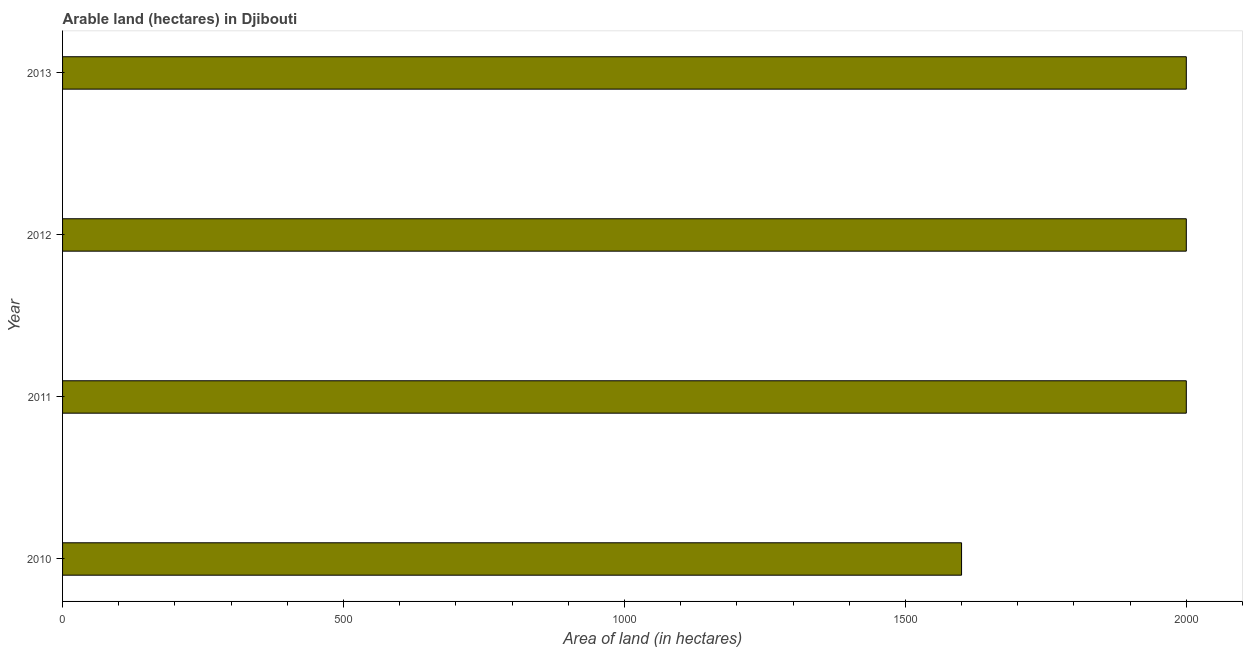Does the graph contain any zero values?
Provide a short and direct response. No. What is the title of the graph?
Your answer should be very brief. Arable land (hectares) in Djibouti. What is the label or title of the X-axis?
Your answer should be compact. Area of land (in hectares). What is the label or title of the Y-axis?
Keep it short and to the point. Year. What is the area of land in 2010?
Provide a succinct answer. 1600. Across all years, what is the minimum area of land?
Make the answer very short. 1600. In which year was the area of land minimum?
Ensure brevity in your answer.  2010. What is the sum of the area of land?
Your response must be concise. 7600. What is the difference between the area of land in 2011 and 2012?
Provide a succinct answer. 0. What is the average area of land per year?
Your answer should be very brief. 1900. What is the median area of land?
Your response must be concise. 2000. Do a majority of the years between 2010 and 2012 (inclusive) have area of land greater than 1500 hectares?
Your answer should be compact. Yes. Is the area of land in 2012 less than that in 2013?
Your response must be concise. No. Is the difference between the area of land in 2010 and 2012 greater than the difference between any two years?
Give a very brief answer. Yes. What is the difference between the highest and the second highest area of land?
Offer a terse response. 0. How many bars are there?
Provide a short and direct response. 4. Are all the bars in the graph horizontal?
Provide a short and direct response. Yes. What is the Area of land (in hectares) in 2010?
Make the answer very short. 1600. What is the Area of land (in hectares) in 2013?
Give a very brief answer. 2000. What is the difference between the Area of land (in hectares) in 2010 and 2011?
Ensure brevity in your answer.  -400. What is the difference between the Area of land (in hectares) in 2010 and 2012?
Your response must be concise. -400. What is the difference between the Area of land (in hectares) in 2010 and 2013?
Provide a short and direct response. -400. What is the ratio of the Area of land (in hectares) in 2010 to that in 2011?
Offer a terse response. 0.8. What is the ratio of the Area of land (in hectares) in 2010 to that in 2013?
Offer a terse response. 0.8. What is the ratio of the Area of land (in hectares) in 2011 to that in 2013?
Offer a terse response. 1. What is the ratio of the Area of land (in hectares) in 2012 to that in 2013?
Make the answer very short. 1. 